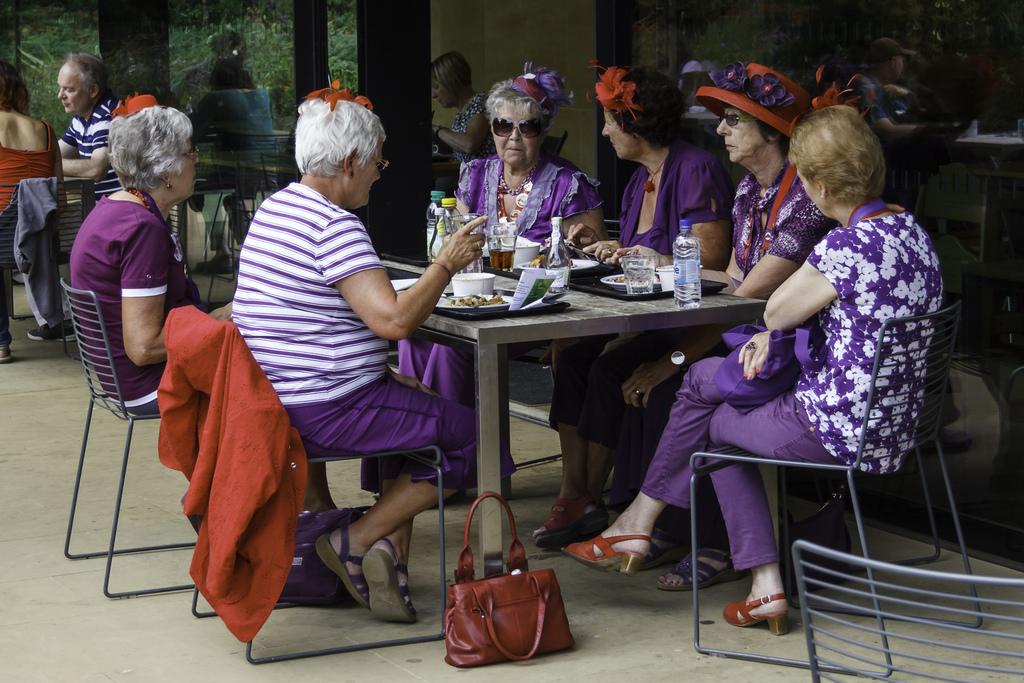How many people are in the image? There is a group of people in the image. What are the people doing in the image? The people are sitting on chairs. Where are the chairs located in relation to the table? The chairs are near a table. What items can be seen on the table? There are cups, plates, glasses, and bottles on the table. What is visible in the background of the image? There is a building in the background of the image. What type of pen is being used by the people in the image? There is no pen present in the image; the people are sitting on chairs near a table with cups, plates, glasses, and bottles. 